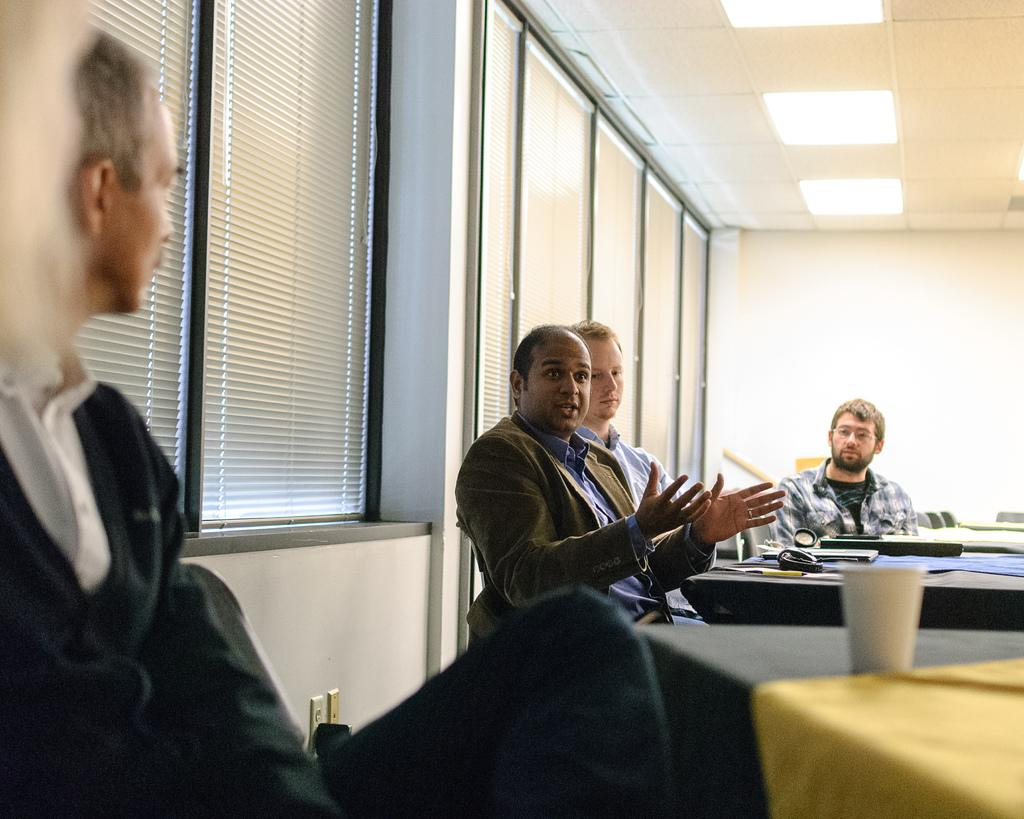What are the people in the image doing? The people in the image are sitting. Where are the people sitting in relation to the tables? The people are sitting in front of the tables. What can be seen on the tables? There are objects placed on the tables. What is on the roof in the image? There are lights on the roof. What architectural feature can be seen on the walls in the image? There are windows on the walls. Can you hear the people in the image talking? The image is a still picture, so it does not capture any sounds, including people talking. 